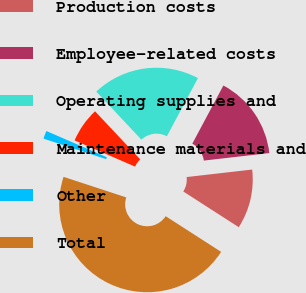<chart> <loc_0><loc_0><loc_500><loc_500><pie_chart><fcel>Production costs<fcel>Employee-related costs<fcel>Operating supplies and<fcel>Maintenance materials and<fcel>Other<fcel>Total<nl><fcel>10.92%<fcel>15.37%<fcel>19.82%<fcel>6.48%<fcel>1.47%<fcel>45.94%<nl></chart> 